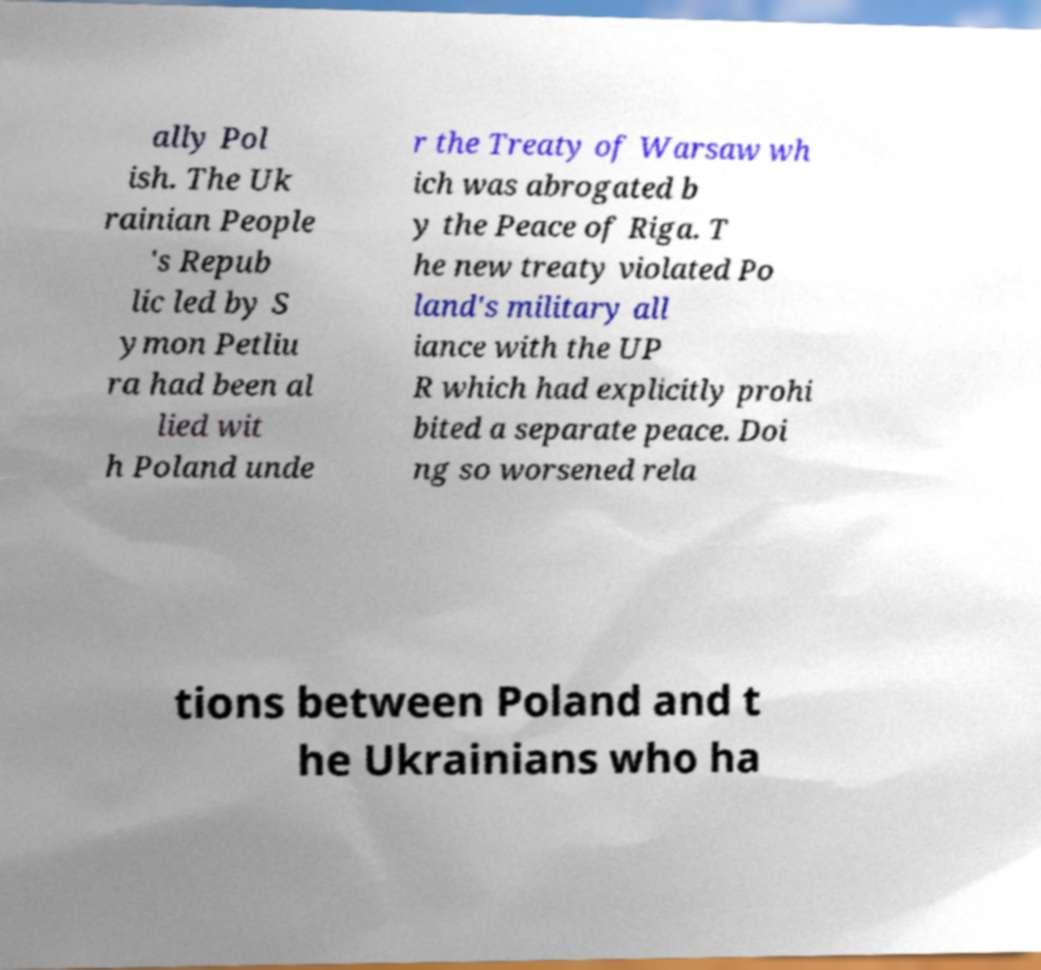For documentation purposes, I need the text within this image transcribed. Could you provide that? ally Pol ish. The Uk rainian People 's Repub lic led by S ymon Petliu ra had been al lied wit h Poland unde r the Treaty of Warsaw wh ich was abrogated b y the Peace of Riga. T he new treaty violated Po land's military all iance with the UP R which had explicitly prohi bited a separate peace. Doi ng so worsened rela tions between Poland and t he Ukrainians who ha 